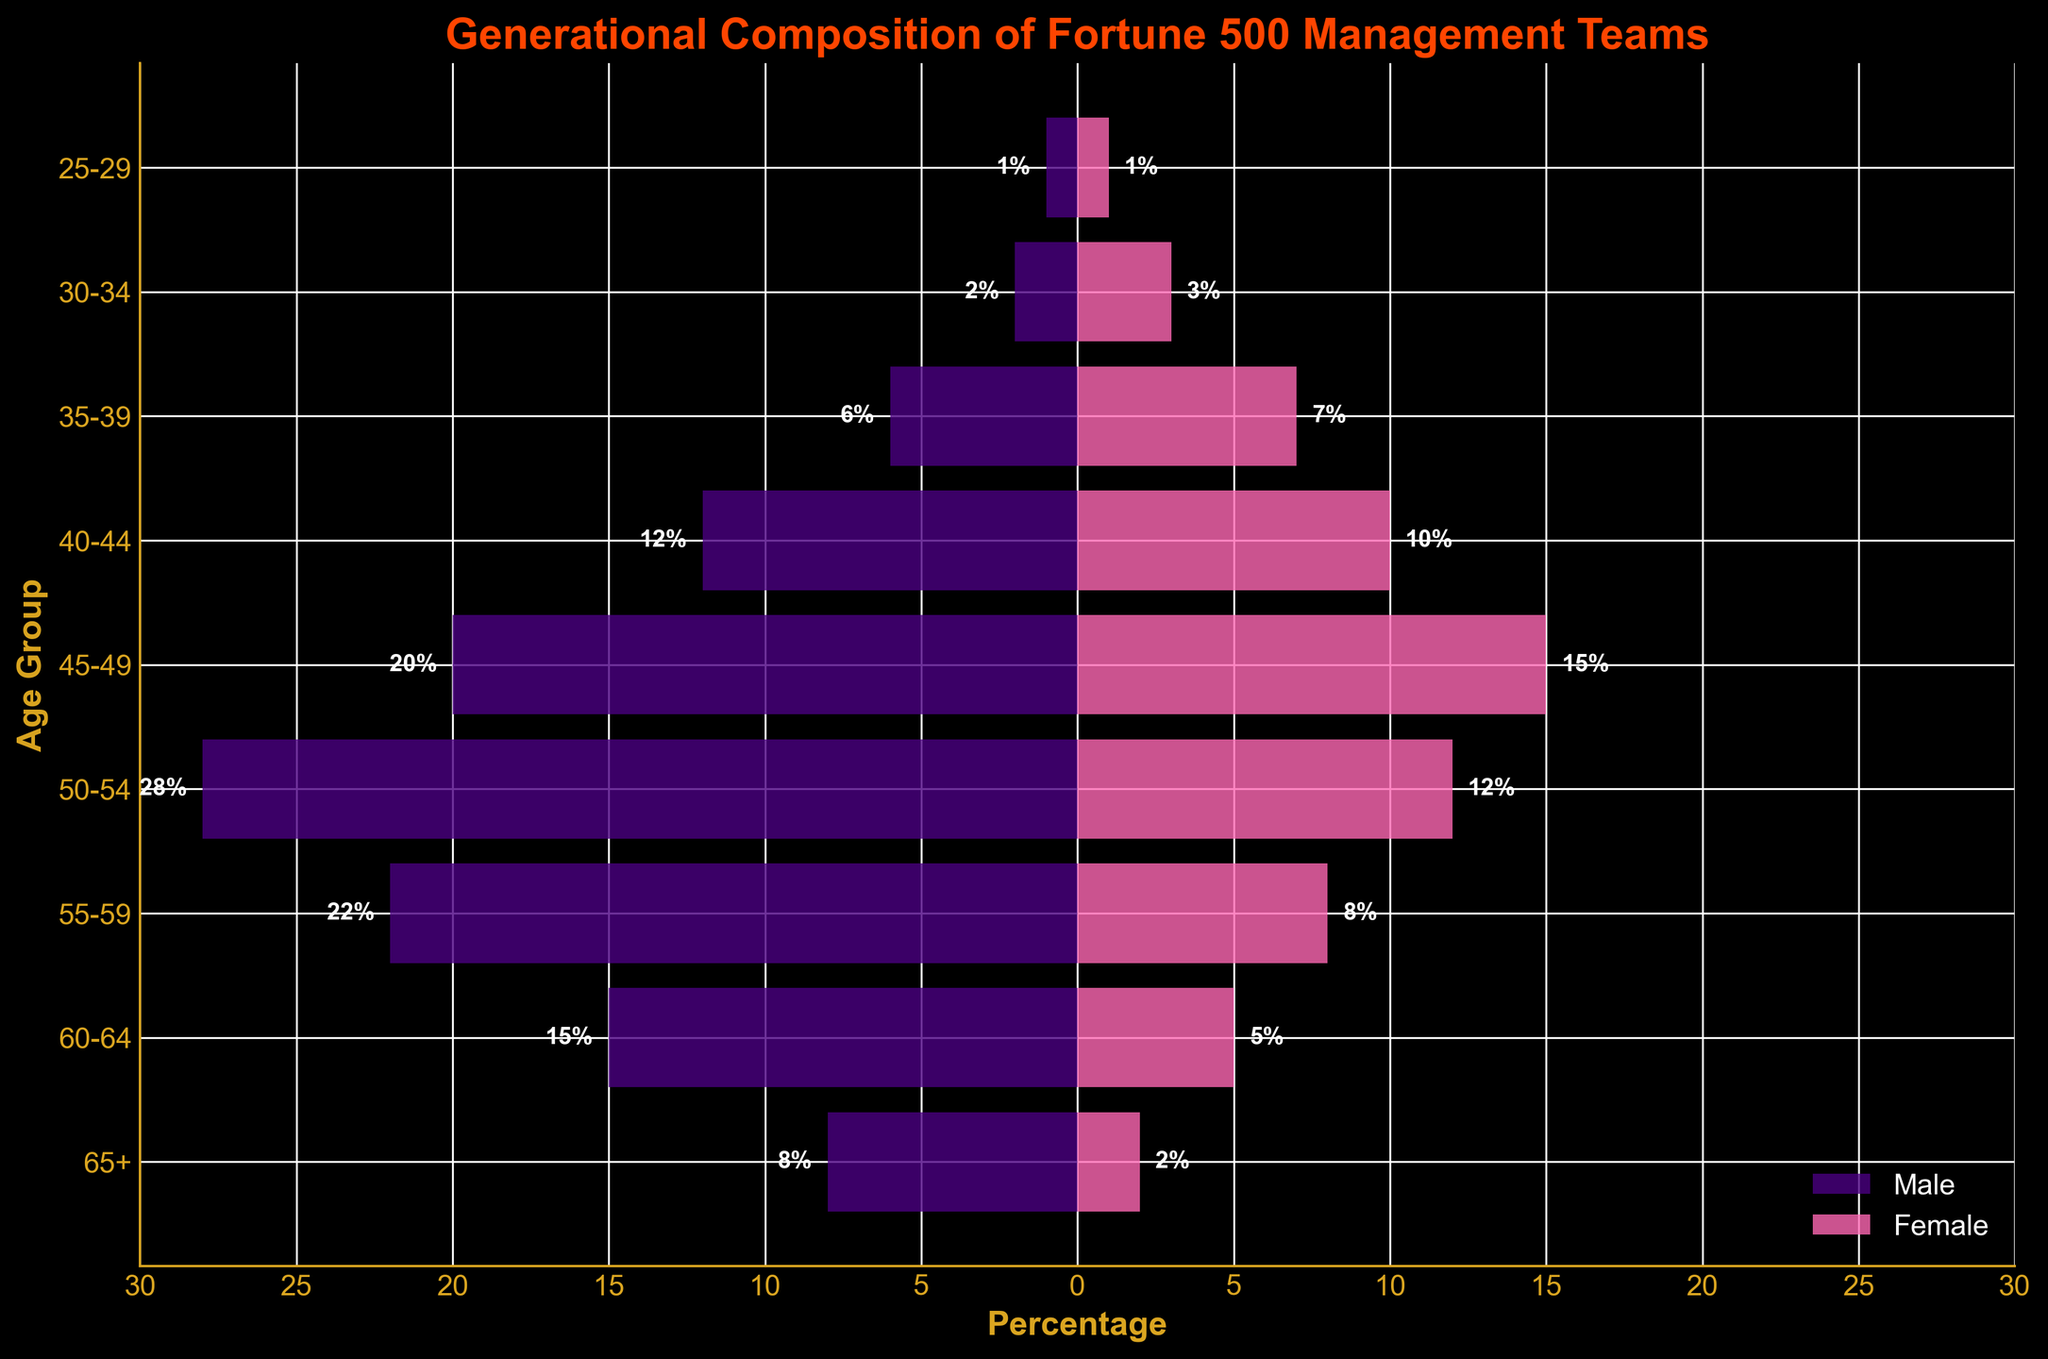How many age groups are represented in the figure? Count the distinct age ranges listed on the y-axis.
Answer: 9 What is the title of the figure? Read the title text displayed at the top of the figure.
Answer: Generational Composition of Fortune 500 Management Teams How many males are there in the 55-59 age group? Look at the horizontal bar for males in the 55-59 age group: the bar extends to the left, indicating a value of 22%.
Answer: 22 What is the total percentage of people aged 60 and above in the management teams? Add the percentages of both males and females in the age groups 60-64 and 65+: (15 + 5) + (8 + 2) = 30%
Answer: 30 Which gender has a higher representation in the 45-49 age group? Observe the length of the horizontal bars for both males and females in the 45-49 age group: the female bar is longer (15%) compared to males (20%).
Answer: Male Compare the number of males and females in the 30-34 age group Check the percentage values for both genders: males (2%) and females (3%).
Answer: There are more females What age group has the highest representation among males? Identify the longest horizontal bar on the left side (males): the 50-54 age group has the highest value (28%).
Answer: 50-54 What is the combined percentage of males aged 40-44 and 45-49? Sum the percentages of males in the respective age groups: (12 + 20) = 32%
Answer: 32 Which age group has the least representation in the management teams? Identify the shortest bars (both genders) on the chart: the 25-29 age group has the least representation with 1% each for males and females.
Answer: 25-29 What insight does the difference in representation between younger and older age groups provide regarding succession planning? Compare the representation in younger age groups (e.g., 25-34 years) to older groups (e.g., 50-65+ years). The representation decreases significantly for younger groups. This suggests a lack of younger professionals in management, indicating potential succession planning issues.
Answer: Indicates potential succession planning issues due to fewer younger professionals 